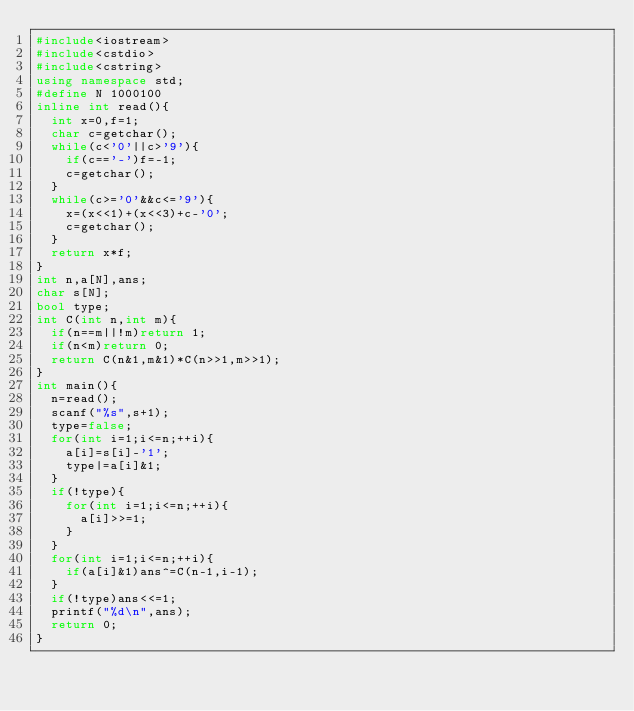Convert code to text. <code><loc_0><loc_0><loc_500><loc_500><_C++_>#include<iostream>
#include<cstdio>
#include<cstring>
using namespace std;
#define N 1000100
inline int read(){
	int x=0,f=1;
	char c=getchar();
	while(c<'0'||c>'9'){
		if(c=='-')f=-1;
		c=getchar();
	}
	while(c>='0'&&c<='9'){
		x=(x<<1)+(x<<3)+c-'0';
		c=getchar();
	}
	return x*f;
}
int n,a[N],ans;
char s[N];
bool type;
int C(int n,int m){
	if(n==m||!m)return 1;
	if(n<m)return 0;
	return C(n&1,m&1)*C(n>>1,m>>1);
}
int main(){
	n=read();
	scanf("%s",s+1);
	type=false;
	for(int i=1;i<=n;++i){
		a[i]=s[i]-'1';
		type|=a[i]&1;
	}
	if(!type){
		for(int i=1;i<=n;++i){
			a[i]>>=1;
		}
	}
	for(int i=1;i<=n;++i){
		if(a[i]&1)ans^=C(n-1,i-1);
	}
	if(!type)ans<<=1;
	printf("%d\n",ans);
	return 0;
}

</code> 